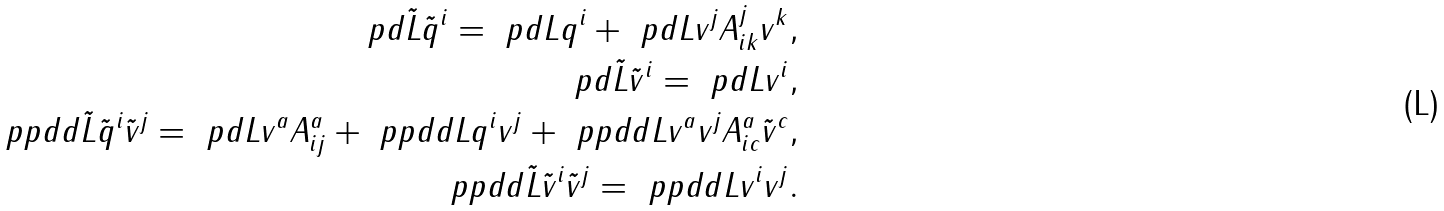Convert formula to latex. <formula><loc_0><loc_0><loc_500><loc_500>\ p d { \tilde { L } } { \tilde { q } ^ { i } } = \ p d { L } { q ^ { i } } + \ p d { L } { v ^ { j } } A ^ { j } _ { i k } v ^ { k } , \\ \ p d { \tilde { L } } { \tilde { v } ^ { i } } = \ p d { L } { v ^ { i } } , \\ \ p p d d { \tilde { L } } { \tilde { q } ^ { i } } { \tilde { v } ^ { j } } = \ p d { L } { v ^ { a } } A ^ { a } _ { i j } + \ p p d d { L } { q ^ { i } } { v ^ { j } } + \ p p d d { L } { v ^ { a } } { v ^ { j } } A ^ { a } _ { i c } { \tilde { v } } ^ { c } , \\ \ p p d d { \tilde { L } } { \tilde { v } ^ { i } } { \tilde { v } ^ { j } } = \ p p d d { L } { v ^ { i } } { v ^ { j } } .</formula> 